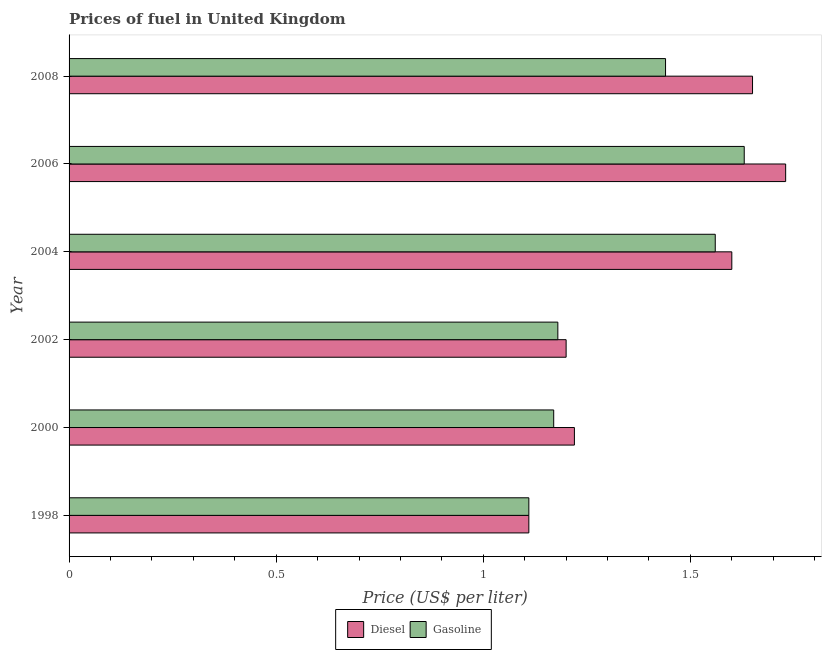Are the number of bars per tick equal to the number of legend labels?
Provide a succinct answer. Yes. Are the number of bars on each tick of the Y-axis equal?
Provide a short and direct response. Yes. What is the label of the 5th group of bars from the top?
Your answer should be very brief. 2000. In how many cases, is the number of bars for a given year not equal to the number of legend labels?
Give a very brief answer. 0. What is the gasoline price in 2002?
Keep it short and to the point. 1.18. Across all years, what is the maximum gasoline price?
Ensure brevity in your answer.  1.63. Across all years, what is the minimum gasoline price?
Provide a short and direct response. 1.11. What is the total diesel price in the graph?
Your answer should be very brief. 8.51. What is the difference between the gasoline price in 1998 and that in 2002?
Your answer should be very brief. -0.07. What is the difference between the diesel price in 2006 and the gasoline price in 2004?
Provide a short and direct response. 0.17. What is the average diesel price per year?
Provide a succinct answer. 1.42. In the year 2006, what is the difference between the gasoline price and diesel price?
Your answer should be very brief. -0.1. What is the ratio of the diesel price in 2002 to that in 2006?
Keep it short and to the point. 0.69. Is the difference between the gasoline price in 2000 and 2002 greater than the difference between the diesel price in 2000 and 2002?
Offer a terse response. No. What is the difference between the highest and the lowest gasoline price?
Provide a succinct answer. 0.52. Is the sum of the diesel price in 1998 and 2006 greater than the maximum gasoline price across all years?
Your response must be concise. Yes. What does the 2nd bar from the top in 2002 represents?
Your answer should be very brief. Diesel. What does the 1st bar from the bottom in 2008 represents?
Ensure brevity in your answer.  Diesel. How many legend labels are there?
Provide a succinct answer. 2. How are the legend labels stacked?
Offer a very short reply. Horizontal. What is the title of the graph?
Offer a terse response. Prices of fuel in United Kingdom. Does "Commercial service imports" appear as one of the legend labels in the graph?
Your answer should be compact. No. What is the label or title of the X-axis?
Provide a succinct answer. Price (US$ per liter). What is the Price (US$ per liter) in Diesel in 1998?
Offer a very short reply. 1.11. What is the Price (US$ per liter) of Gasoline in 1998?
Provide a succinct answer. 1.11. What is the Price (US$ per liter) in Diesel in 2000?
Make the answer very short. 1.22. What is the Price (US$ per liter) of Gasoline in 2000?
Offer a terse response. 1.17. What is the Price (US$ per liter) in Gasoline in 2002?
Make the answer very short. 1.18. What is the Price (US$ per liter) of Diesel in 2004?
Offer a very short reply. 1.6. What is the Price (US$ per liter) of Gasoline in 2004?
Keep it short and to the point. 1.56. What is the Price (US$ per liter) in Diesel in 2006?
Make the answer very short. 1.73. What is the Price (US$ per liter) in Gasoline in 2006?
Keep it short and to the point. 1.63. What is the Price (US$ per liter) of Diesel in 2008?
Ensure brevity in your answer.  1.65. What is the Price (US$ per liter) in Gasoline in 2008?
Your answer should be very brief. 1.44. Across all years, what is the maximum Price (US$ per liter) in Diesel?
Offer a terse response. 1.73. Across all years, what is the maximum Price (US$ per liter) of Gasoline?
Give a very brief answer. 1.63. Across all years, what is the minimum Price (US$ per liter) of Diesel?
Your answer should be very brief. 1.11. Across all years, what is the minimum Price (US$ per liter) in Gasoline?
Give a very brief answer. 1.11. What is the total Price (US$ per liter) of Diesel in the graph?
Offer a terse response. 8.51. What is the total Price (US$ per liter) of Gasoline in the graph?
Give a very brief answer. 8.09. What is the difference between the Price (US$ per liter) of Diesel in 1998 and that in 2000?
Keep it short and to the point. -0.11. What is the difference between the Price (US$ per liter) of Gasoline in 1998 and that in 2000?
Your answer should be compact. -0.06. What is the difference between the Price (US$ per liter) of Diesel in 1998 and that in 2002?
Your response must be concise. -0.09. What is the difference between the Price (US$ per liter) in Gasoline in 1998 and that in 2002?
Provide a succinct answer. -0.07. What is the difference between the Price (US$ per liter) of Diesel in 1998 and that in 2004?
Make the answer very short. -0.49. What is the difference between the Price (US$ per liter) of Gasoline in 1998 and that in 2004?
Ensure brevity in your answer.  -0.45. What is the difference between the Price (US$ per liter) of Diesel in 1998 and that in 2006?
Make the answer very short. -0.62. What is the difference between the Price (US$ per liter) in Gasoline in 1998 and that in 2006?
Make the answer very short. -0.52. What is the difference between the Price (US$ per liter) of Diesel in 1998 and that in 2008?
Make the answer very short. -0.54. What is the difference between the Price (US$ per liter) of Gasoline in 1998 and that in 2008?
Your response must be concise. -0.33. What is the difference between the Price (US$ per liter) of Diesel in 2000 and that in 2002?
Your answer should be compact. 0.02. What is the difference between the Price (US$ per liter) of Gasoline in 2000 and that in 2002?
Keep it short and to the point. -0.01. What is the difference between the Price (US$ per liter) in Diesel in 2000 and that in 2004?
Your answer should be very brief. -0.38. What is the difference between the Price (US$ per liter) in Gasoline in 2000 and that in 2004?
Make the answer very short. -0.39. What is the difference between the Price (US$ per liter) of Diesel in 2000 and that in 2006?
Keep it short and to the point. -0.51. What is the difference between the Price (US$ per liter) of Gasoline in 2000 and that in 2006?
Offer a terse response. -0.46. What is the difference between the Price (US$ per liter) of Diesel in 2000 and that in 2008?
Provide a short and direct response. -0.43. What is the difference between the Price (US$ per liter) of Gasoline in 2000 and that in 2008?
Keep it short and to the point. -0.27. What is the difference between the Price (US$ per liter) in Gasoline in 2002 and that in 2004?
Make the answer very short. -0.38. What is the difference between the Price (US$ per liter) of Diesel in 2002 and that in 2006?
Your answer should be very brief. -0.53. What is the difference between the Price (US$ per liter) of Gasoline in 2002 and that in 2006?
Keep it short and to the point. -0.45. What is the difference between the Price (US$ per liter) in Diesel in 2002 and that in 2008?
Give a very brief answer. -0.45. What is the difference between the Price (US$ per liter) of Gasoline in 2002 and that in 2008?
Make the answer very short. -0.26. What is the difference between the Price (US$ per liter) of Diesel in 2004 and that in 2006?
Your response must be concise. -0.13. What is the difference between the Price (US$ per liter) of Gasoline in 2004 and that in 2006?
Your response must be concise. -0.07. What is the difference between the Price (US$ per liter) in Gasoline in 2004 and that in 2008?
Ensure brevity in your answer.  0.12. What is the difference between the Price (US$ per liter) of Gasoline in 2006 and that in 2008?
Offer a terse response. 0.19. What is the difference between the Price (US$ per liter) of Diesel in 1998 and the Price (US$ per liter) of Gasoline in 2000?
Provide a short and direct response. -0.06. What is the difference between the Price (US$ per liter) of Diesel in 1998 and the Price (US$ per liter) of Gasoline in 2002?
Make the answer very short. -0.07. What is the difference between the Price (US$ per liter) in Diesel in 1998 and the Price (US$ per liter) in Gasoline in 2004?
Your response must be concise. -0.45. What is the difference between the Price (US$ per liter) of Diesel in 1998 and the Price (US$ per liter) of Gasoline in 2006?
Offer a terse response. -0.52. What is the difference between the Price (US$ per liter) in Diesel in 1998 and the Price (US$ per liter) in Gasoline in 2008?
Provide a short and direct response. -0.33. What is the difference between the Price (US$ per liter) of Diesel in 2000 and the Price (US$ per liter) of Gasoline in 2004?
Keep it short and to the point. -0.34. What is the difference between the Price (US$ per liter) of Diesel in 2000 and the Price (US$ per liter) of Gasoline in 2006?
Offer a terse response. -0.41. What is the difference between the Price (US$ per liter) of Diesel in 2000 and the Price (US$ per liter) of Gasoline in 2008?
Ensure brevity in your answer.  -0.22. What is the difference between the Price (US$ per liter) of Diesel in 2002 and the Price (US$ per liter) of Gasoline in 2004?
Offer a terse response. -0.36. What is the difference between the Price (US$ per liter) in Diesel in 2002 and the Price (US$ per liter) in Gasoline in 2006?
Offer a terse response. -0.43. What is the difference between the Price (US$ per liter) in Diesel in 2002 and the Price (US$ per liter) in Gasoline in 2008?
Offer a terse response. -0.24. What is the difference between the Price (US$ per liter) of Diesel in 2004 and the Price (US$ per liter) of Gasoline in 2006?
Give a very brief answer. -0.03. What is the difference between the Price (US$ per liter) of Diesel in 2004 and the Price (US$ per liter) of Gasoline in 2008?
Your answer should be very brief. 0.16. What is the difference between the Price (US$ per liter) in Diesel in 2006 and the Price (US$ per liter) in Gasoline in 2008?
Give a very brief answer. 0.29. What is the average Price (US$ per liter) of Diesel per year?
Your answer should be compact. 1.42. What is the average Price (US$ per liter) in Gasoline per year?
Your answer should be very brief. 1.35. In the year 1998, what is the difference between the Price (US$ per liter) of Diesel and Price (US$ per liter) of Gasoline?
Provide a succinct answer. 0. In the year 2000, what is the difference between the Price (US$ per liter) of Diesel and Price (US$ per liter) of Gasoline?
Keep it short and to the point. 0.05. In the year 2002, what is the difference between the Price (US$ per liter) in Diesel and Price (US$ per liter) in Gasoline?
Provide a succinct answer. 0.02. In the year 2006, what is the difference between the Price (US$ per liter) of Diesel and Price (US$ per liter) of Gasoline?
Offer a terse response. 0.1. In the year 2008, what is the difference between the Price (US$ per liter) of Diesel and Price (US$ per liter) of Gasoline?
Your answer should be very brief. 0.21. What is the ratio of the Price (US$ per liter) in Diesel in 1998 to that in 2000?
Make the answer very short. 0.91. What is the ratio of the Price (US$ per liter) in Gasoline in 1998 to that in 2000?
Your response must be concise. 0.95. What is the ratio of the Price (US$ per liter) of Diesel in 1998 to that in 2002?
Your answer should be compact. 0.93. What is the ratio of the Price (US$ per liter) in Gasoline in 1998 to that in 2002?
Your response must be concise. 0.94. What is the ratio of the Price (US$ per liter) of Diesel in 1998 to that in 2004?
Make the answer very short. 0.69. What is the ratio of the Price (US$ per liter) in Gasoline in 1998 to that in 2004?
Your response must be concise. 0.71. What is the ratio of the Price (US$ per liter) in Diesel in 1998 to that in 2006?
Make the answer very short. 0.64. What is the ratio of the Price (US$ per liter) of Gasoline in 1998 to that in 2006?
Offer a very short reply. 0.68. What is the ratio of the Price (US$ per liter) in Diesel in 1998 to that in 2008?
Keep it short and to the point. 0.67. What is the ratio of the Price (US$ per liter) of Gasoline in 1998 to that in 2008?
Your answer should be compact. 0.77. What is the ratio of the Price (US$ per liter) in Diesel in 2000 to that in 2002?
Make the answer very short. 1.02. What is the ratio of the Price (US$ per liter) in Diesel in 2000 to that in 2004?
Offer a terse response. 0.76. What is the ratio of the Price (US$ per liter) in Gasoline in 2000 to that in 2004?
Make the answer very short. 0.75. What is the ratio of the Price (US$ per liter) of Diesel in 2000 to that in 2006?
Give a very brief answer. 0.71. What is the ratio of the Price (US$ per liter) in Gasoline in 2000 to that in 2006?
Give a very brief answer. 0.72. What is the ratio of the Price (US$ per liter) in Diesel in 2000 to that in 2008?
Provide a succinct answer. 0.74. What is the ratio of the Price (US$ per liter) of Gasoline in 2000 to that in 2008?
Keep it short and to the point. 0.81. What is the ratio of the Price (US$ per liter) in Diesel in 2002 to that in 2004?
Ensure brevity in your answer.  0.75. What is the ratio of the Price (US$ per liter) in Gasoline in 2002 to that in 2004?
Your response must be concise. 0.76. What is the ratio of the Price (US$ per liter) in Diesel in 2002 to that in 2006?
Your answer should be compact. 0.69. What is the ratio of the Price (US$ per liter) of Gasoline in 2002 to that in 2006?
Provide a short and direct response. 0.72. What is the ratio of the Price (US$ per liter) of Diesel in 2002 to that in 2008?
Your answer should be compact. 0.73. What is the ratio of the Price (US$ per liter) of Gasoline in 2002 to that in 2008?
Your answer should be compact. 0.82. What is the ratio of the Price (US$ per liter) in Diesel in 2004 to that in 2006?
Provide a short and direct response. 0.92. What is the ratio of the Price (US$ per liter) in Gasoline in 2004 to that in 2006?
Your answer should be compact. 0.96. What is the ratio of the Price (US$ per liter) of Diesel in 2004 to that in 2008?
Make the answer very short. 0.97. What is the ratio of the Price (US$ per liter) of Diesel in 2006 to that in 2008?
Provide a short and direct response. 1.05. What is the ratio of the Price (US$ per liter) in Gasoline in 2006 to that in 2008?
Make the answer very short. 1.13. What is the difference between the highest and the second highest Price (US$ per liter) of Gasoline?
Your response must be concise. 0.07. What is the difference between the highest and the lowest Price (US$ per liter) of Diesel?
Your answer should be very brief. 0.62. What is the difference between the highest and the lowest Price (US$ per liter) of Gasoline?
Make the answer very short. 0.52. 